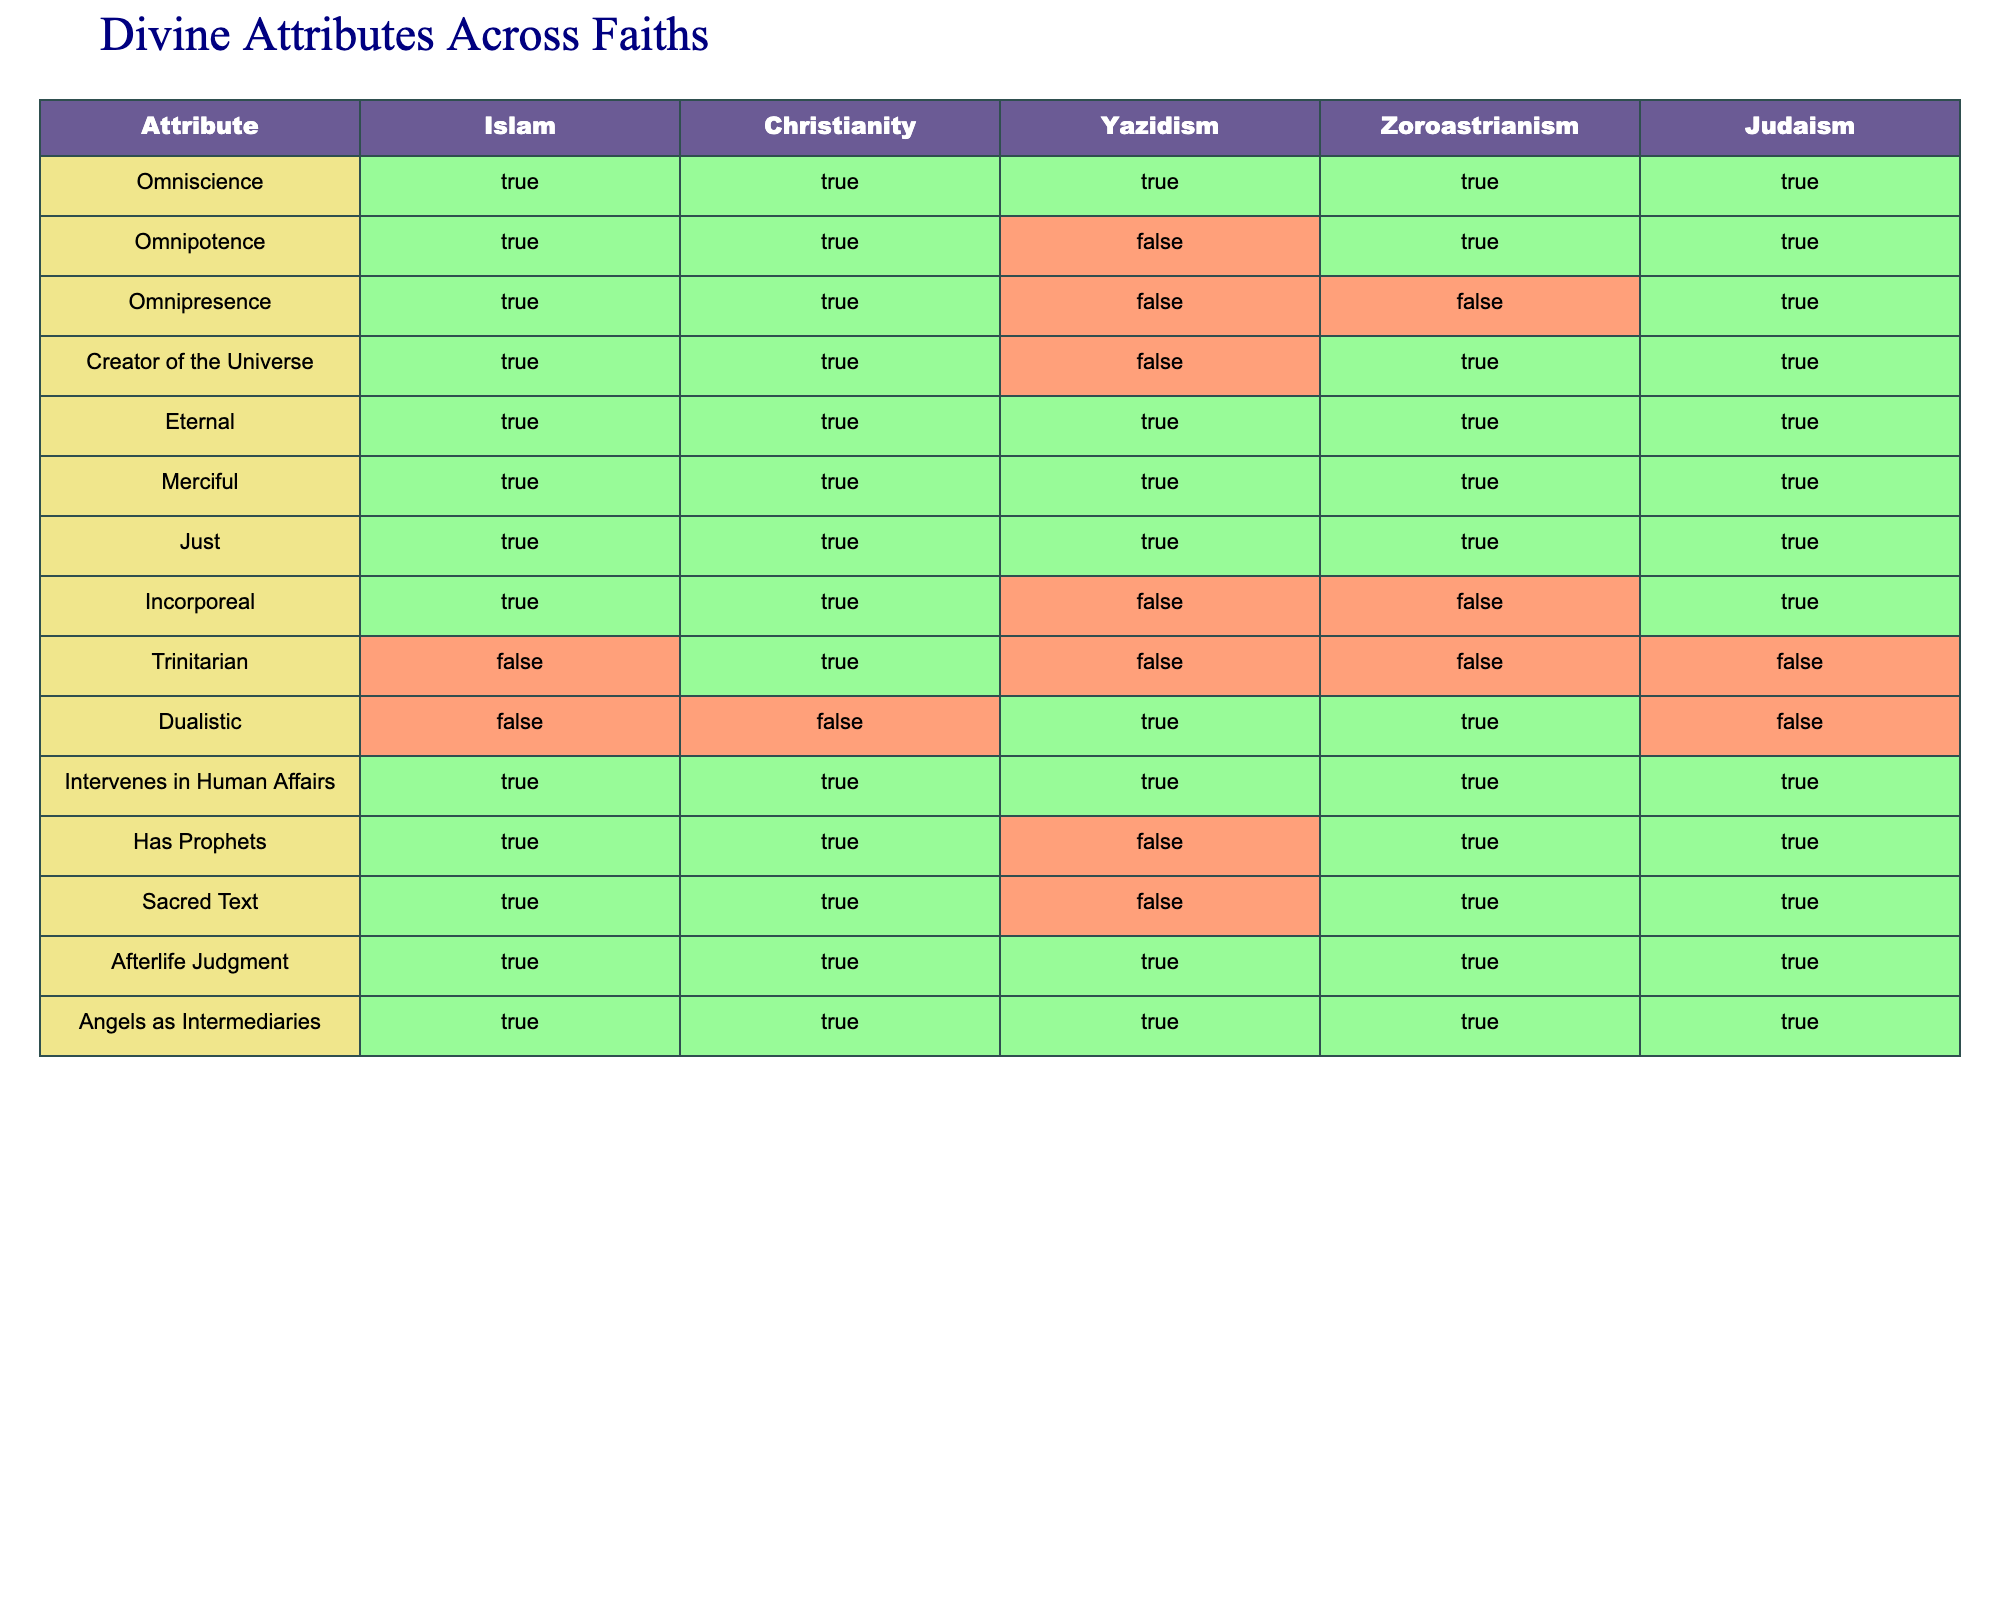What attributes are shared by Islam and Christianity? Both Islam and Christianity share the attributes of Omniscience, Omnipotence, Omnipresence, Creator of the Universe, Eternal, Merciful, Just, Intervenes in Human Affairs, Has Prophets, Sacred Text, Afterlife Judgment, and Angels as Intermediaries, as they both have "True" for these attributes in the table.
Answer: 11 attributes Is Yazidism considered Omnipotent according to this comparison? In the table, Yazidism has "False" under the Omnipotence attribute, indicating that it does not hold this characteristic.
Answer: No How many faiths have the attribute of Incorporeal? From the table, we see that Islam, Christianity, and Judaism are marked as "True" for the Incorporeal attribute, which totals three faiths that possess this characteristic.
Answer: 3 faiths If we take the number of attributes that Zoroastrianism has as "True" and subtract the number of attributes it has as "False", what is the result? Zoroastrianism has 6 attributes marked as "True" (Omniscience, Omnipotence, Eternal, Merciful, Just, Intervenes in Human Affairs) and 5 marked as "False" (Omnipresence, Creator of the Universe, Dualistic, Incorporeal, Has Prophets, Sacred Text). Thus, 6 - 5 = 1.
Answer: 1 Which faiths have the attribute of Dualistic? Looking at the table, only Yazidism and Zoroastrianism are marked as "True" for the Dualistic attribute.
Answer: Yazidism, Zoroastrianism How many total attributes does Judaism have that are marked as "True"? By examining the table, Judaism has 9 attributes marked as "True" (Omniscience, Omnipotence, Eternal, Merciful, Just, Incorporeal, Intervenes in Human Affairs, Has Prophets, Sacred Text, Afterlife Judgment, Angels as Intermediaries).
Answer: 10 attributes Is there a faith that possesses all attributes as "True"? No, upon reviewing the table, there is no single faith that has all attributes marked as "True"; each faith has at least one attribute marked "False".
Answer: No Which attribute has the most number of faiths marked as "True"? The attributes Omniscience, Eternal, Merciful, Just, and Intervenes in Human Affairs have all five faiths marked as "True." Thus, these attributes are the most common across all listed faiths.
Answer: 5 attributes 